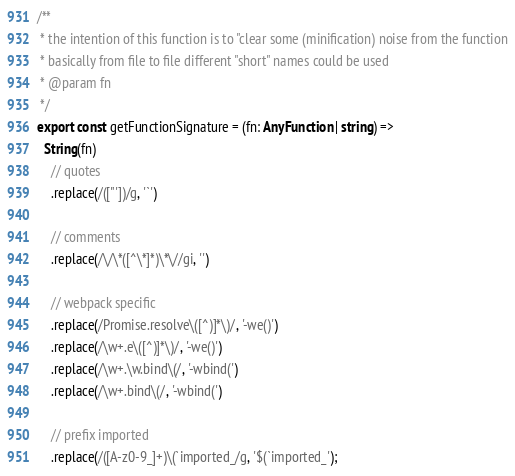<code> <loc_0><loc_0><loc_500><loc_500><_TypeScript_>
/**
 * the intention of this function is to "clear some (minification) noise from the function
 * basically from file to file different "short" names could be used
 * @param fn
 */
export const getFunctionSignature = (fn: AnyFunction | string) =>
  String(fn)
    // quotes
    .replace(/(["'])/g, '`')

    // comments
    .replace(/\/\*([^\*]*)\*\//gi, '')

    // webpack specific
    .replace(/Promise.resolve\([^)]*\)/, '-we()')
    .replace(/\w+.e\([^)]*\)/, '-we()')
    .replace(/\w+.\w.bind\(/, '-wbind(')
    .replace(/\w+.bind\(/, '-wbind(')

    // prefix imported
    .replace(/([A-z0-9_]+)\(`imported_/g, '$(`imported_');
</code> 